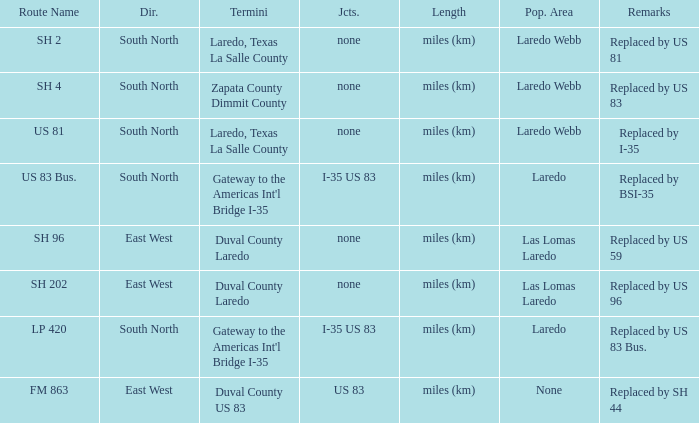How many junctions feature "replaced by bsi-35" in their remarks section? 1.0. 